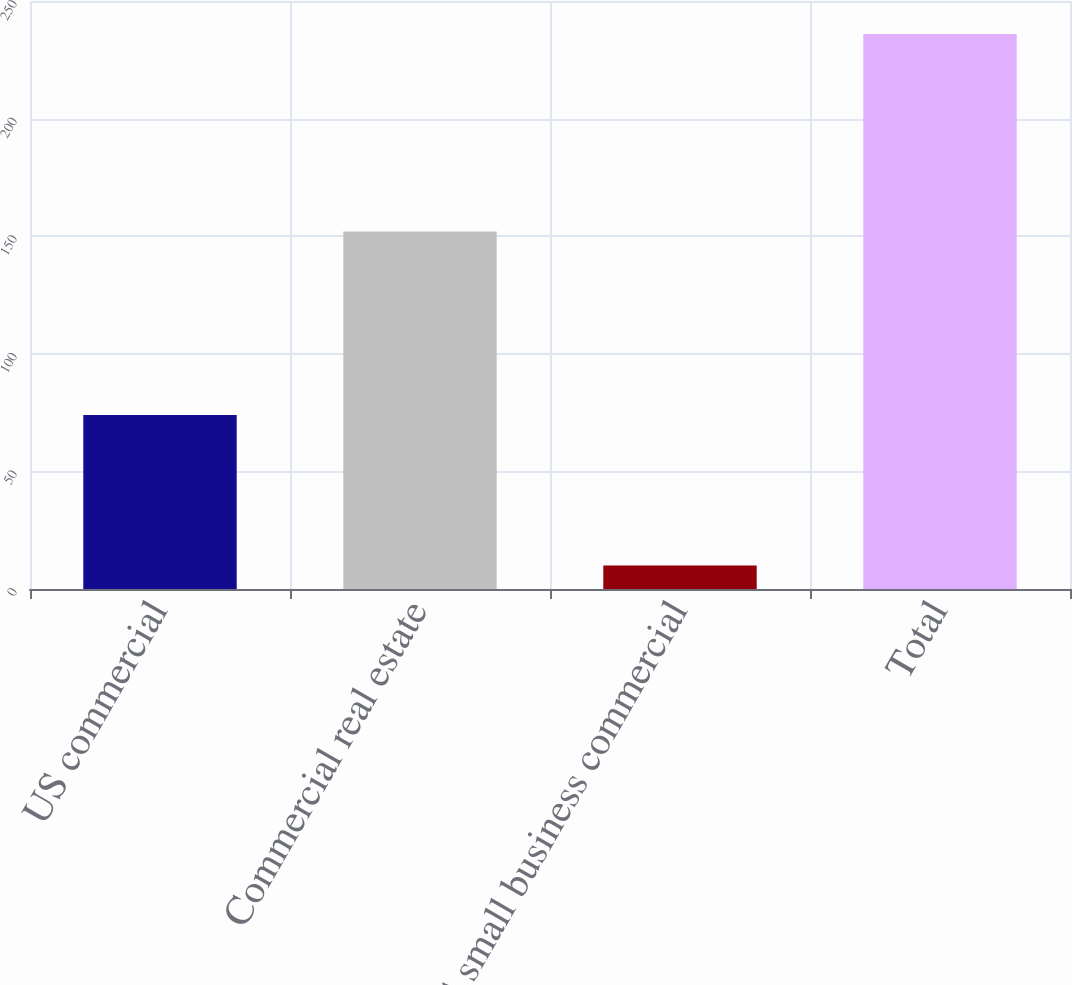<chart> <loc_0><loc_0><loc_500><loc_500><bar_chart><fcel>US commercial<fcel>Commercial real estate<fcel>US small business commercial<fcel>Total<nl><fcel>74<fcel>152<fcel>10<fcel>236<nl></chart> 